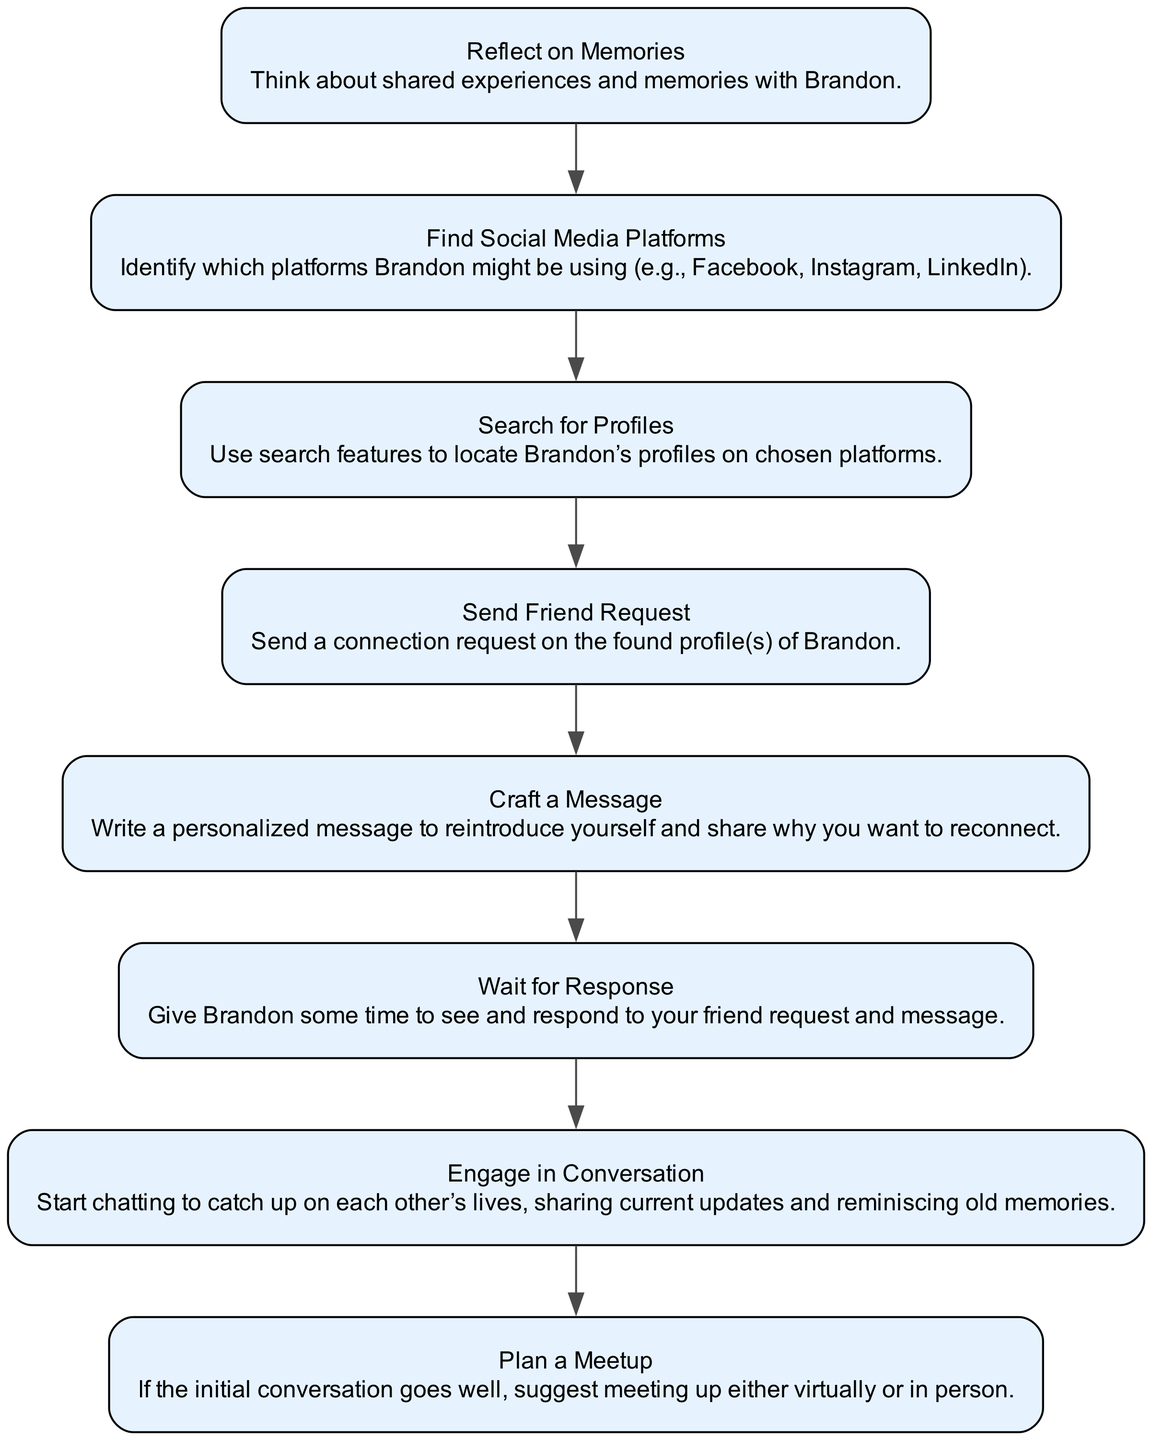What is the first step in the process? The diagram indicates that the first step is labeled "Reflect on Memories." Therefore, one should begin by thinking about the shared experiences and memories.
Answer: Reflect on Memories What is the last step in the process? The last step mentioned in the diagram is "Plan a Meetup," which involves suggesting a meeting after the initial conversation.
Answer: Plan a Meetup How many total steps are identified in the process? There are eight steps indicated in the diagram, from reflecting on memories to planning a meetup.
Answer: Eight Which step comes after sending a friend request? Following "Send Friend Request," the next step is "Craft a Message." Hence, after sending the request, one must write a personalized message.
Answer: Craft a Message Which steps are directly related to engaging with Brandon? The steps "Engage in Conversation" and "Plan a Meetup" are directly related to interacting with Brandon after making contact. This shows that the interaction continues beyond initial introductions.
Answer: Engage in Conversation, Plan a Meetup If the message is crafted and sent, what is the next step? After crafting the message, the subsequent step is to "Wait for Response." This indicates patience before further actions can be taken.
Answer: Wait for Response What type of platforms should be identified in the process? The process emphasizes "Find Social Media Platforms," meaning users should identify social media channels like Facebook, Instagram, or LinkedIn where Brandon could be present.
Answer: Social Media Platforms How do the steps indicate the flow of the reconnection process? The steps are sequentially linked by edges, illustrating a clear flow from reflecting on memories through to planning a meetup. Each step builds on the previous one, creating a structured process.
Answer: Sequential Flow 